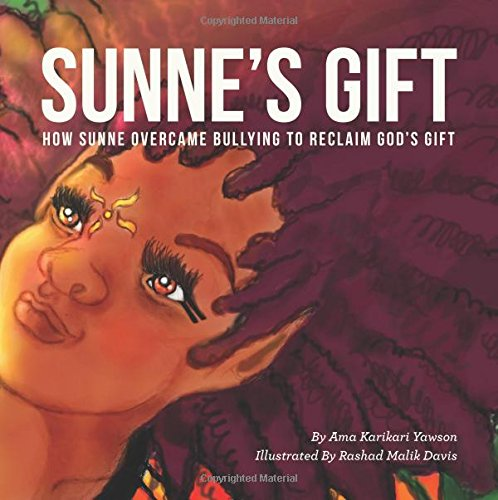What is the title of this book? The title of this colorful and vividly illustrated children's book is 'Sunne's Gift: How Sunne Overcame Bullying to Reclaim God's Gift.' 